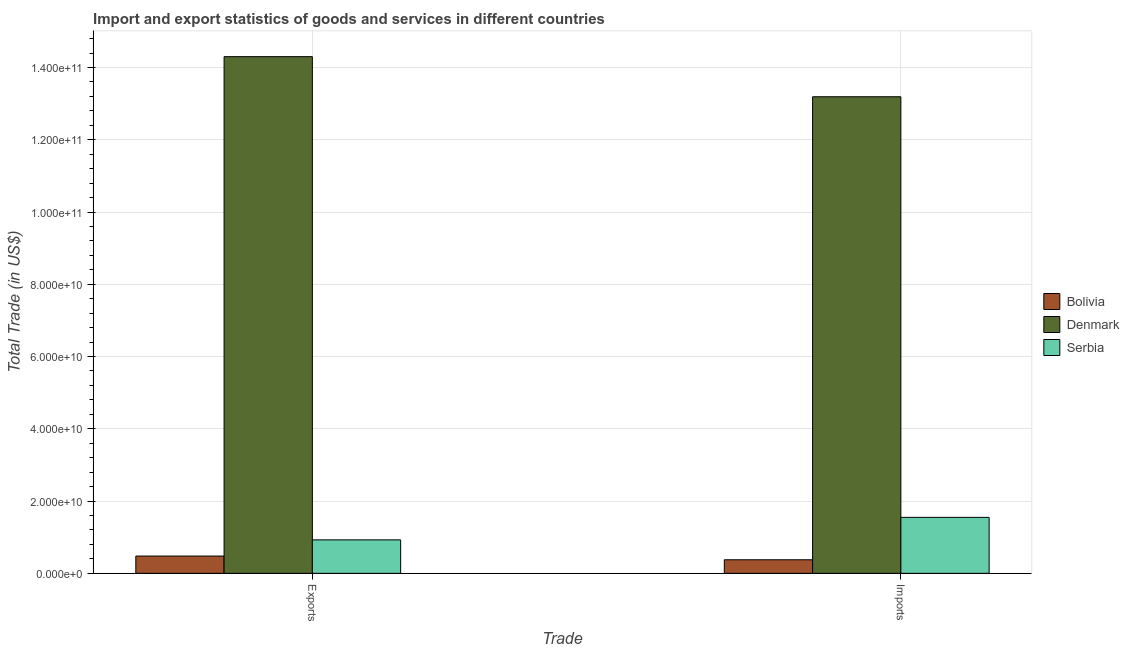How many groups of bars are there?
Your answer should be compact. 2. Are the number of bars on each tick of the X-axis equal?
Provide a succinct answer. Yes. What is the label of the 1st group of bars from the left?
Make the answer very short. Exports. What is the imports of goods and services in Denmark?
Your answer should be compact. 1.32e+11. Across all countries, what is the maximum imports of goods and services?
Your answer should be very brief. 1.32e+11. Across all countries, what is the minimum export of goods and services?
Give a very brief answer. 4.78e+09. In which country was the imports of goods and services minimum?
Provide a succinct answer. Bolivia. What is the total export of goods and services in the graph?
Offer a very short reply. 1.57e+11. What is the difference between the export of goods and services in Bolivia and that in Serbia?
Offer a very short reply. -4.48e+09. What is the difference between the imports of goods and services in Denmark and the export of goods and services in Bolivia?
Offer a terse response. 1.27e+11. What is the average export of goods and services per country?
Make the answer very short. 5.23e+1. What is the difference between the imports of goods and services and export of goods and services in Serbia?
Keep it short and to the point. 6.22e+09. In how many countries, is the imports of goods and services greater than 76000000000 US$?
Ensure brevity in your answer.  1. What is the ratio of the export of goods and services in Denmark to that in Bolivia?
Your response must be concise. 29.89. What does the 3rd bar from the left in Imports represents?
Keep it short and to the point. Serbia. What does the 1st bar from the right in Imports represents?
Your answer should be very brief. Serbia. How many bars are there?
Make the answer very short. 6. What is the difference between two consecutive major ticks on the Y-axis?
Your answer should be very brief. 2.00e+1. Does the graph contain any zero values?
Your answer should be very brief. No. How many legend labels are there?
Offer a very short reply. 3. What is the title of the graph?
Offer a very short reply. Import and export statistics of goods and services in different countries. Does "Sweden" appear as one of the legend labels in the graph?
Ensure brevity in your answer.  No. What is the label or title of the X-axis?
Offer a very short reply. Trade. What is the label or title of the Y-axis?
Offer a very short reply. Total Trade (in US$). What is the Total Trade (in US$) of Bolivia in Exports?
Offer a very short reply. 4.78e+09. What is the Total Trade (in US$) of Denmark in Exports?
Offer a very short reply. 1.43e+11. What is the Total Trade (in US$) of Serbia in Exports?
Provide a succinct answer. 9.26e+09. What is the Total Trade (in US$) of Bolivia in Imports?
Your answer should be compact. 3.75e+09. What is the Total Trade (in US$) in Denmark in Imports?
Give a very brief answer. 1.32e+11. What is the Total Trade (in US$) in Serbia in Imports?
Your answer should be very brief. 1.55e+1. Across all Trade, what is the maximum Total Trade (in US$) of Bolivia?
Your answer should be very brief. 4.78e+09. Across all Trade, what is the maximum Total Trade (in US$) of Denmark?
Make the answer very short. 1.43e+11. Across all Trade, what is the maximum Total Trade (in US$) of Serbia?
Ensure brevity in your answer.  1.55e+1. Across all Trade, what is the minimum Total Trade (in US$) of Bolivia?
Ensure brevity in your answer.  3.75e+09. Across all Trade, what is the minimum Total Trade (in US$) of Denmark?
Your response must be concise. 1.32e+11. Across all Trade, what is the minimum Total Trade (in US$) in Serbia?
Ensure brevity in your answer.  9.26e+09. What is the total Total Trade (in US$) of Bolivia in the graph?
Keep it short and to the point. 8.54e+09. What is the total Total Trade (in US$) in Denmark in the graph?
Your answer should be compact. 2.75e+11. What is the total Total Trade (in US$) in Serbia in the graph?
Ensure brevity in your answer.  2.48e+1. What is the difference between the Total Trade (in US$) of Bolivia in Exports and that in Imports?
Keep it short and to the point. 1.03e+09. What is the difference between the Total Trade (in US$) in Denmark in Exports and that in Imports?
Your answer should be very brief. 1.11e+1. What is the difference between the Total Trade (in US$) of Serbia in Exports and that in Imports?
Provide a succinct answer. -6.22e+09. What is the difference between the Total Trade (in US$) in Bolivia in Exports and the Total Trade (in US$) in Denmark in Imports?
Provide a succinct answer. -1.27e+11. What is the difference between the Total Trade (in US$) of Bolivia in Exports and the Total Trade (in US$) of Serbia in Imports?
Your answer should be compact. -1.07e+1. What is the difference between the Total Trade (in US$) in Denmark in Exports and the Total Trade (in US$) in Serbia in Imports?
Give a very brief answer. 1.28e+11. What is the average Total Trade (in US$) in Bolivia per Trade?
Ensure brevity in your answer.  4.27e+09. What is the average Total Trade (in US$) in Denmark per Trade?
Give a very brief answer. 1.37e+11. What is the average Total Trade (in US$) in Serbia per Trade?
Offer a very short reply. 1.24e+1. What is the difference between the Total Trade (in US$) in Bolivia and Total Trade (in US$) in Denmark in Exports?
Offer a very short reply. -1.38e+11. What is the difference between the Total Trade (in US$) in Bolivia and Total Trade (in US$) in Serbia in Exports?
Provide a short and direct response. -4.48e+09. What is the difference between the Total Trade (in US$) of Denmark and Total Trade (in US$) of Serbia in Exports?
Your answer should be very brief. 1.34e+11. What is the difference between the Total Trade (in US$) in Bolivia and Total Trade (in US$) in Denmark in Imports?
Your answer should be very brief. -1.28e+11. What is the difference between the Total Trade (in US$) in Bolivia and Total Trade (in US$) in Serbia in Imports?
Offer a very short reply. -1.17e+1. What is the difference between the Total Trade (in US$) in Denmark and Total Trade (in US$) in Serbia in Imports?
Your response must be concise. 1.16e+11. What is the ratio of the Total Trade (in US$) in Bolivia in Exports to that in Imports?
Ensure brevity in your answer.  1.27. What is the ratio of the Total Trade (in US$) in Denmark in Exports to that in Imports?
Offer a very short reply. 1.08. What is the ratio of the Total Trade (in US$) in Serbia in Exports to that in Imports?
Your response must be concise. 0.6. What is the difference between the highest and the second highest Total Trade (in US$) of Bolivia?
Keep it short and to the point. 1.03e+09. What is the difference between the highest and the second highest Total Trade (in US$) of Denmark?
Your answer should be very brief. 1.11e+1. What is the difference between the highest and the second highest Total Trade (in US$) in Serbia?
Make the answer very short. 6.22e+09. What is the difference between the highest and the lowest Total Trade (in US$) in Bolivia?
Make the answer very short. 1.03e+09. What is the difference between the highest and the lowest Total Trade (in US$) of Denmark?
Your answer should be very brief. 1.11e+1. What is the difference between the highest and the lowest Total Trade (in US$) in Serbia?
Make the answer very short. 6.22e+09. 